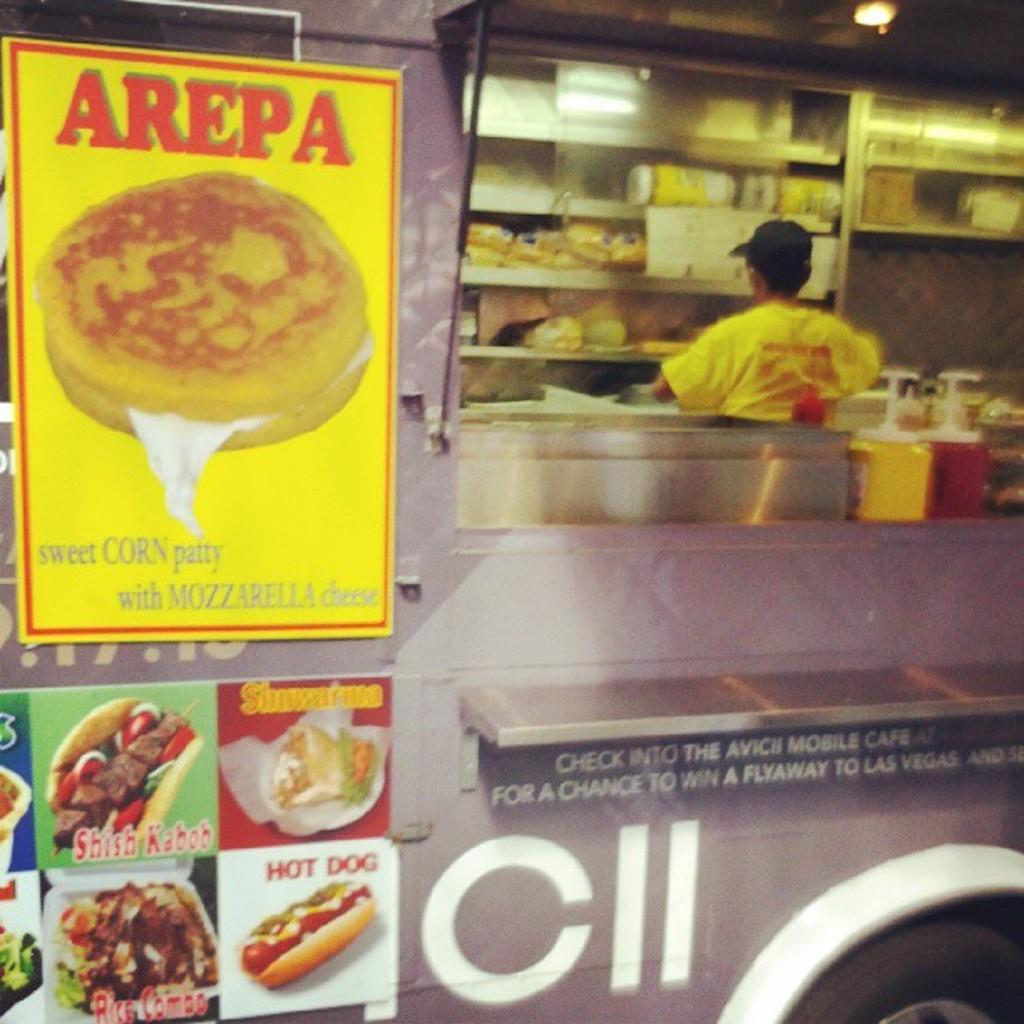In one or two sentences, can you explain what this image depicts? In this picture we can see posts on a vehicle with a person and some objects inside it. 